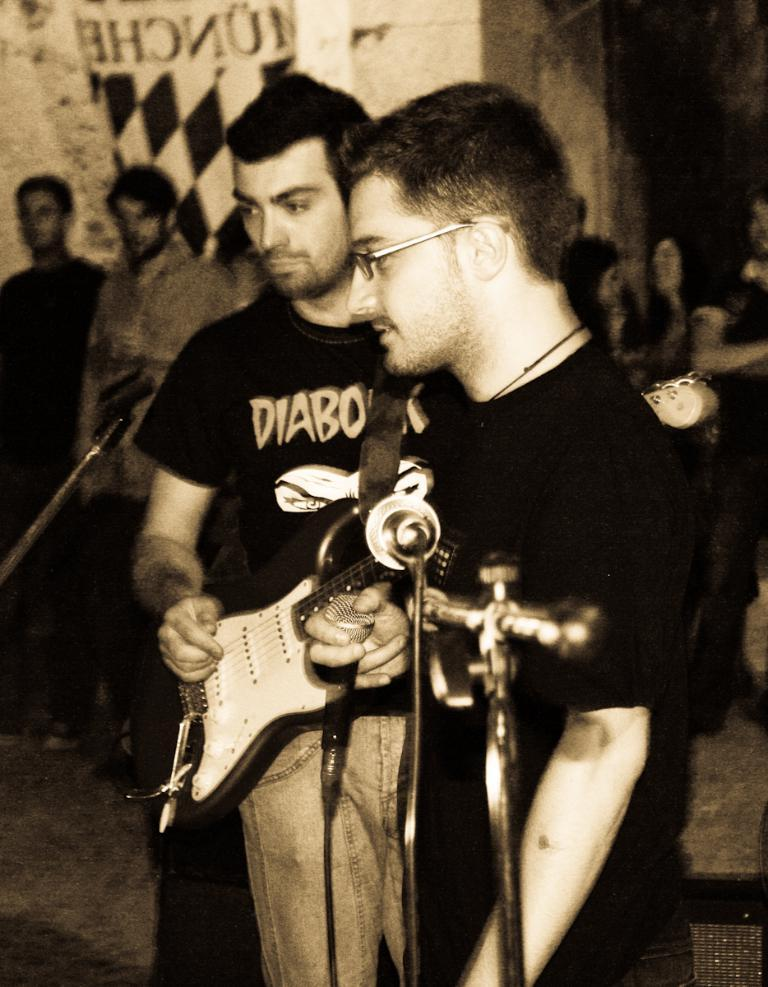What is the man in the image doing? There is a man playing a guitar in the image. Can you describe the other person in the image? There is another man standing in the image. What can be seen in the background of the image? There is a group of people standing in the background of the image. How many cacti are visible in the image? There are no cacti present in the image. What type of frogs can be seen in the image? There are no frogs present in the image. 